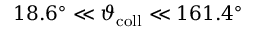Convert formula to latex. <formula><loc_0><loc_0><loc_500><loc_500>1 8 . 6 ^ { \circ } \ll \vartheta _ { c o l l } \ll 1 6 1 . 4 ^ { \circ }</formula> 